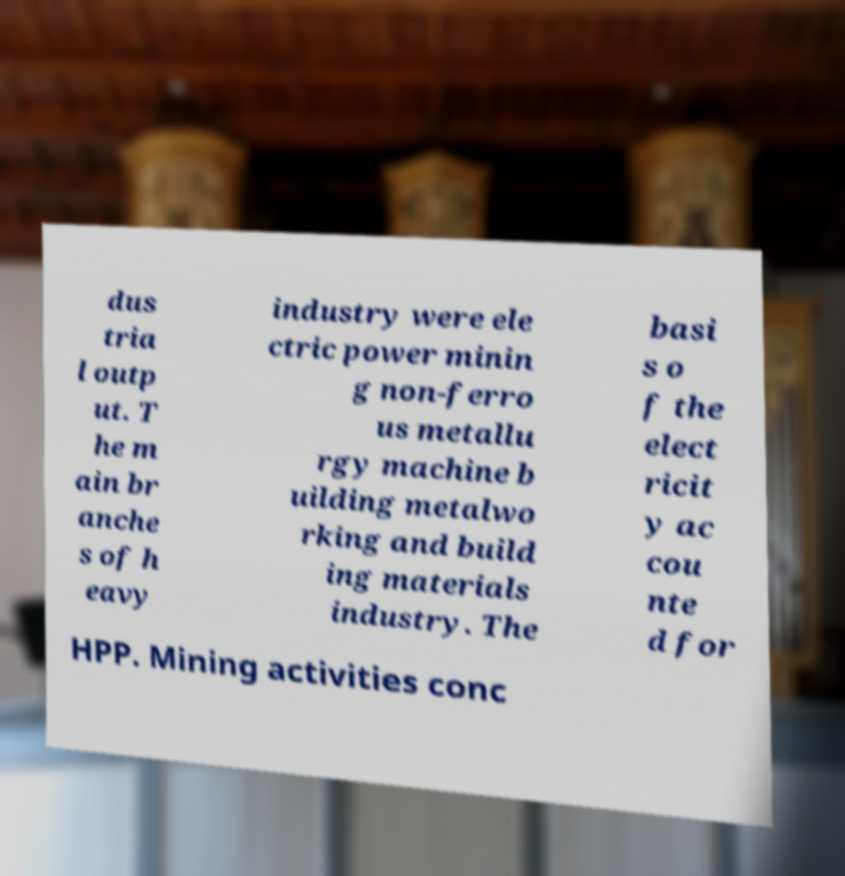I need the written content from this picture converted into text. Can you do that? dus tria l outp ut. T he m ain br anche s of h eavy industry were ele ctric power minin g non-ferro us metallu rgy machine b uilding metalwo rking and build ing materials industry. The basi s o f the elect ricit y ac cou nte d for HPP. Mining activities conc 